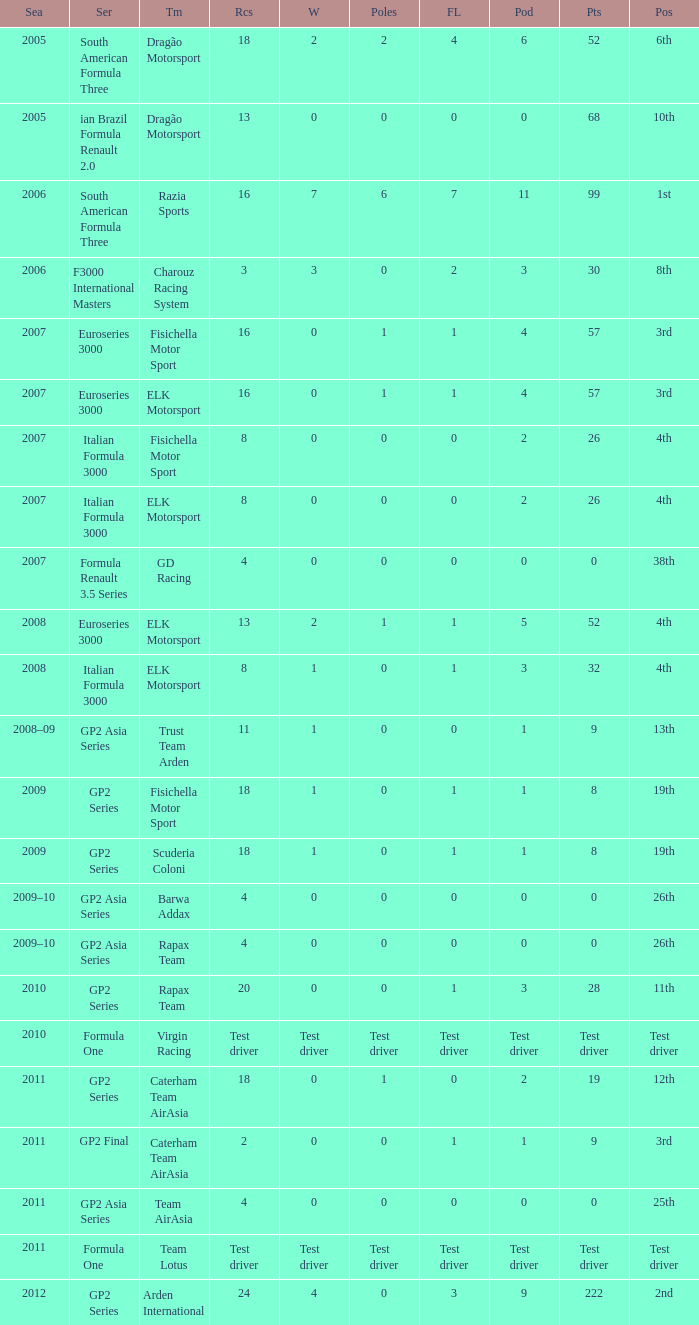What was the F/Laps when the Wins were 0 and the Position was 4th? 0, 0. 